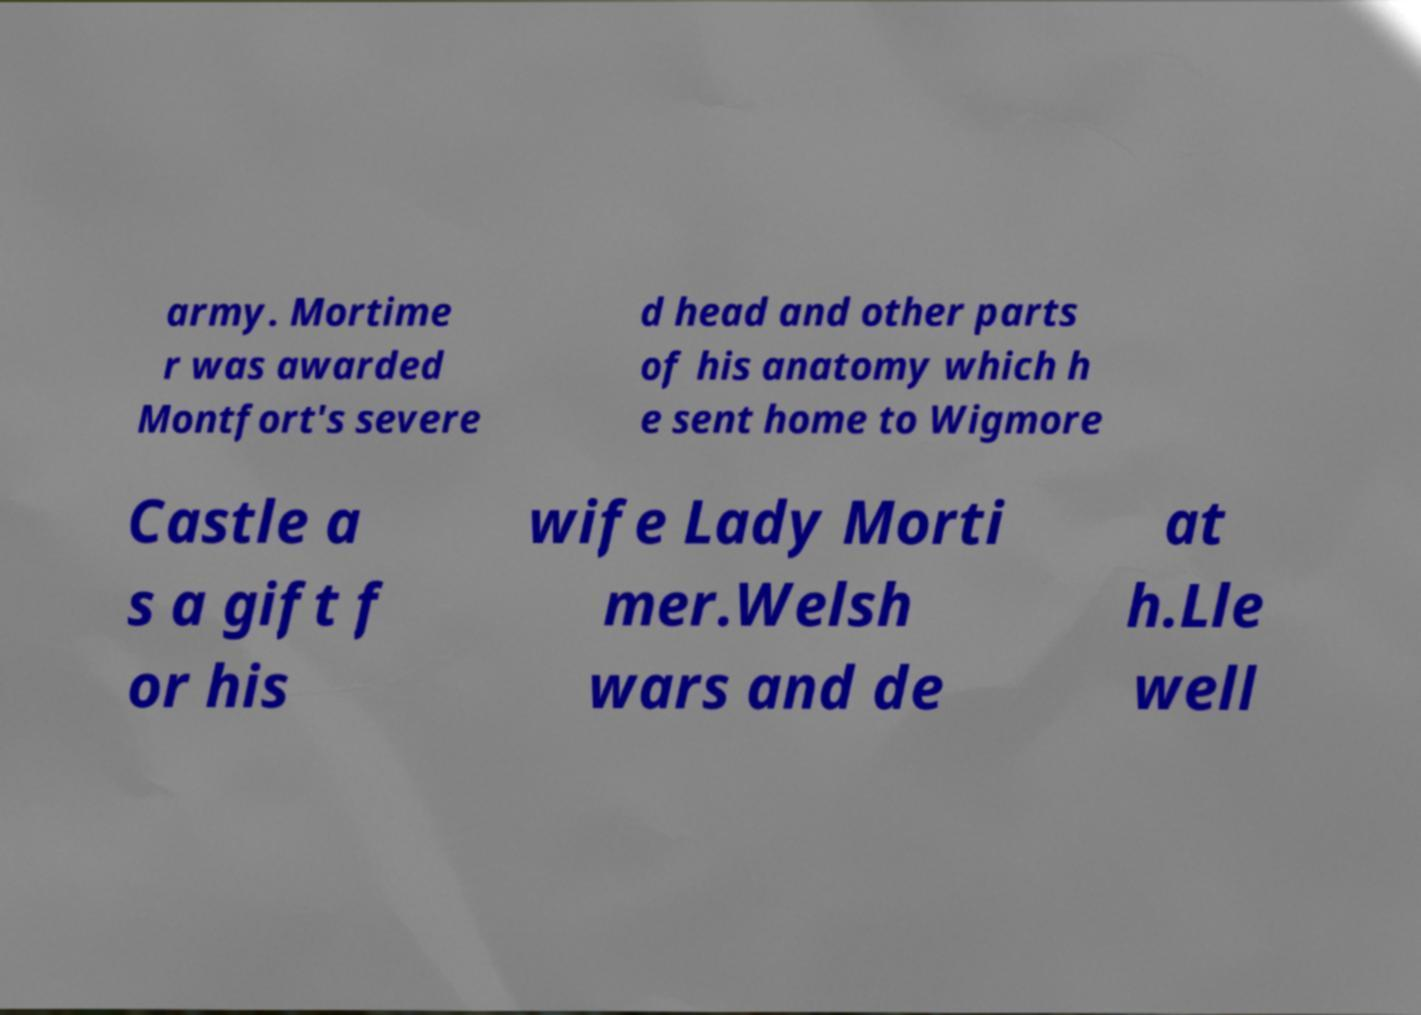Could you extract and type out the text from this image? army. Mortime r was awarded Montfort's severe d head and other parts of his anatomy which h e sent home to Wigmore Castle a s a gift f or his wife Lady Morti mer.Welsh wars and de at h.Lle well 